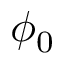Convert formula to latex. <formula><loc_0><loc_0><loc_500><loc_500>\phi _ { 0 }</formula> 